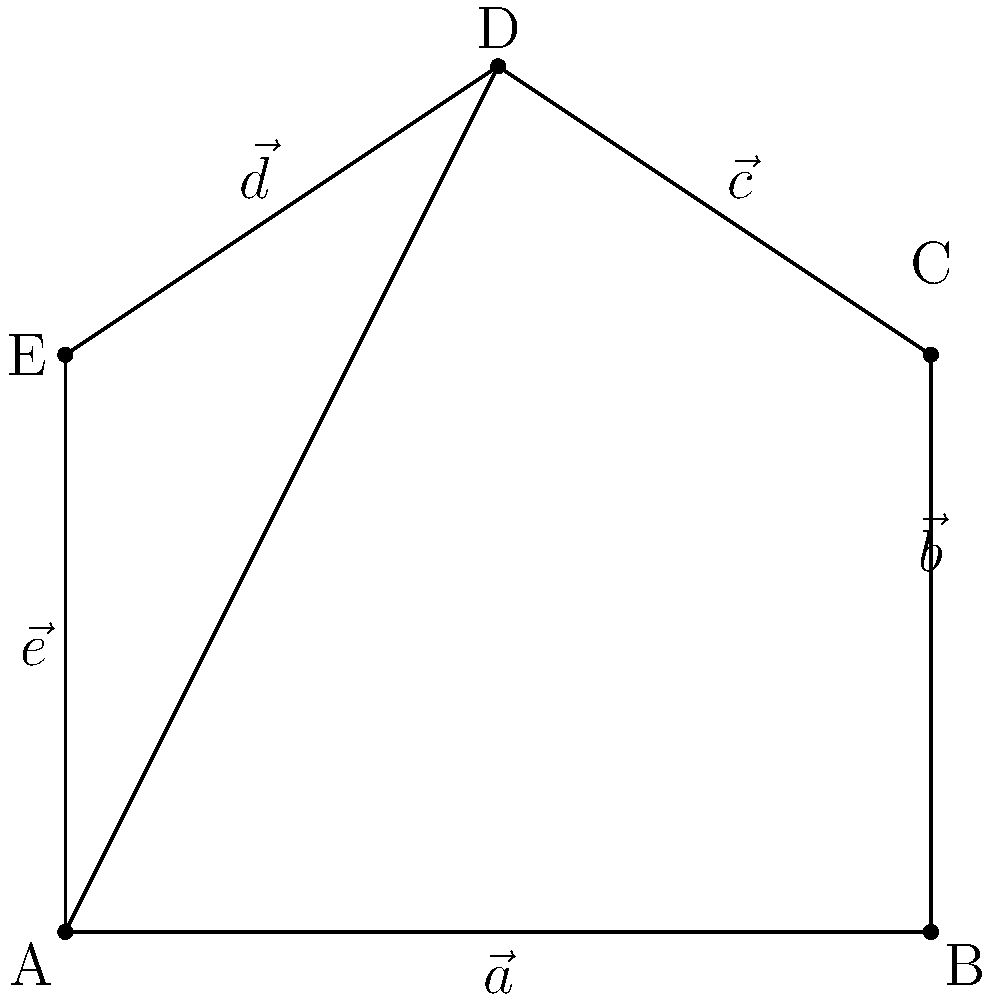A church-shaped building is represented by the vectors $\vec{a}$, $\vec{b}$, $\vec{c}$, $\vec{d}$, and $\vec{e}$ as shown in the diagram. If $\vec{a} = 6\hat{i}$, $\vec{b} = 4\hat{j}$, $\vec{c} = -3\hat{i} + 2\hat{j}$, $\vec{d} = -3\hat{i} + 2\hat{j}$, and $\vec{e} = -4\hat{j}$, calculate the area of the church-shaped building using vector operations. To find the area of the church-shaped building, we can divide it into a rectangle (ABCE) and a triangle (CDE). We'll use the cross product method to calculate the areas.

1. Area of rectangle ABCE:
   $A_{ABCE} = |\vec{a} \times \vec{b}| = |6\hat{i} \times 4\hat{j}| = 24$ square units

2. Area of triangle CDE:
   $A_{CDE} = \frac{1}{2}|\vec{c} \times \vec{d}|$
   $\vec{c} \times \vec{d} = (-3\hat{i} + 2\hat{j}) \times (-3\hat{i} + 2\hat{j}) = (-3 \cdot 2 - 2 \cdot (-3))\hat{k} = -6\hat{k} + 6\hat{k} = 0$
   
   Since the cross product is zero, vectors $\vec{c}$ and $\vec{d}$ are parallel, forming a straight line. Thus, $A_{CDE} = 0$.

3. Total area:
   $A_{total} = A_{ABCE} + A_{CDE} = 24 + 0 = 24$ square units

Therefore, the area of the church-shaped building is 24 square units.
Answer: 24 square units 